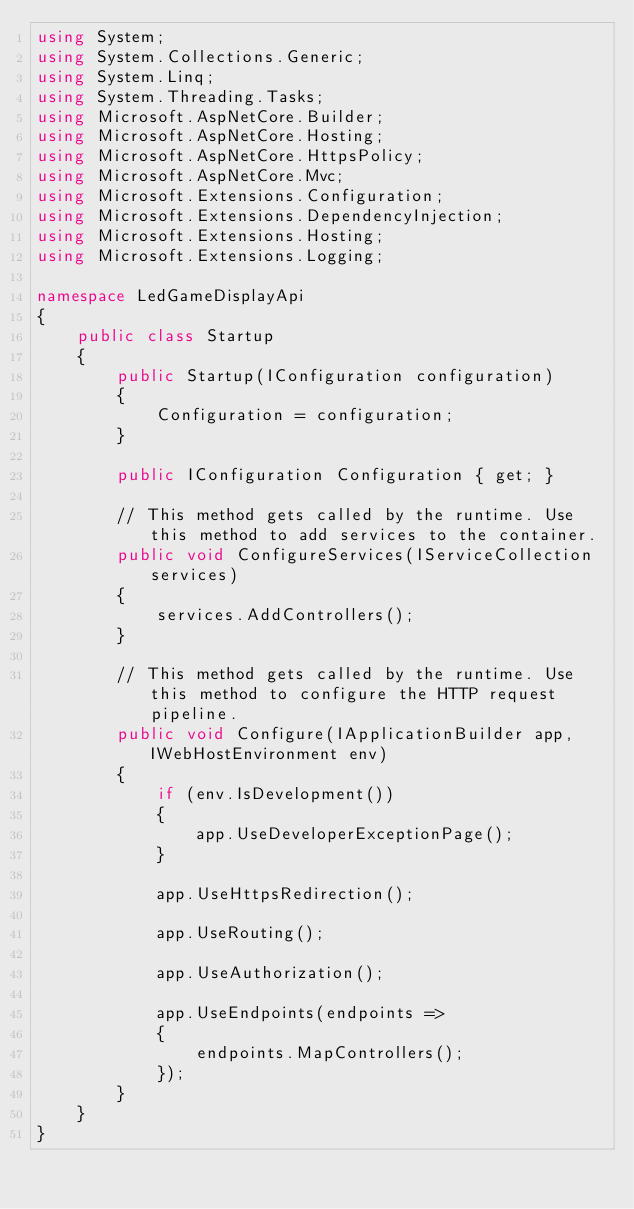Convert code to text. <code><loc_0><loc_0><loc_500><loc_500><_C#_>using System;
using System.Collections.Generic;
using System.Linq;
using System.Threading.Tasks;
using Microsoft.AspNetCore.Builder;
using Microsoft.AspNetCore.Hosting;
using Microsoft.AspNetCore.HttpsPolicy;
using Microsoft.AspNetCore.Mvc;
using Microsoft.Extensions.Configuration;
using Microsoft.Extensions.DependencyInjection;
using Microsoft.Extensions.Hosting;
using Microsoft.Extensions.Logging;

namespace LedGameDisplayApi
{
    public class Startup
    {
        public Startup(IConfiguration configuration)
        {
            Configuration = configuration;
        }

        public IConfiguration Configuration { get; }

        // This method gets called by the runtime. Use this method to add services to the container.
        public void ConfigureServices(IServiceCollection services)
        {
            services.AddControllers();
        }

        // This method gets called by the runtime. Use this method to configure the HTTP request pipeline.
        public void Configure(IApplicationBuilder app, IWebHostEnvironment env)
        {
            if (env.IsDevelopment())
            {
                app.UseDeveloperExceptionPage();
            }

            app.UseHttpsRedirection();

            app.UseRouting();

            app.UseAuthorization();

            app.UseEndpoints(endpoints =>
            {
                endpoints.MapControllers();
            });
        }
    }
}
</code> 